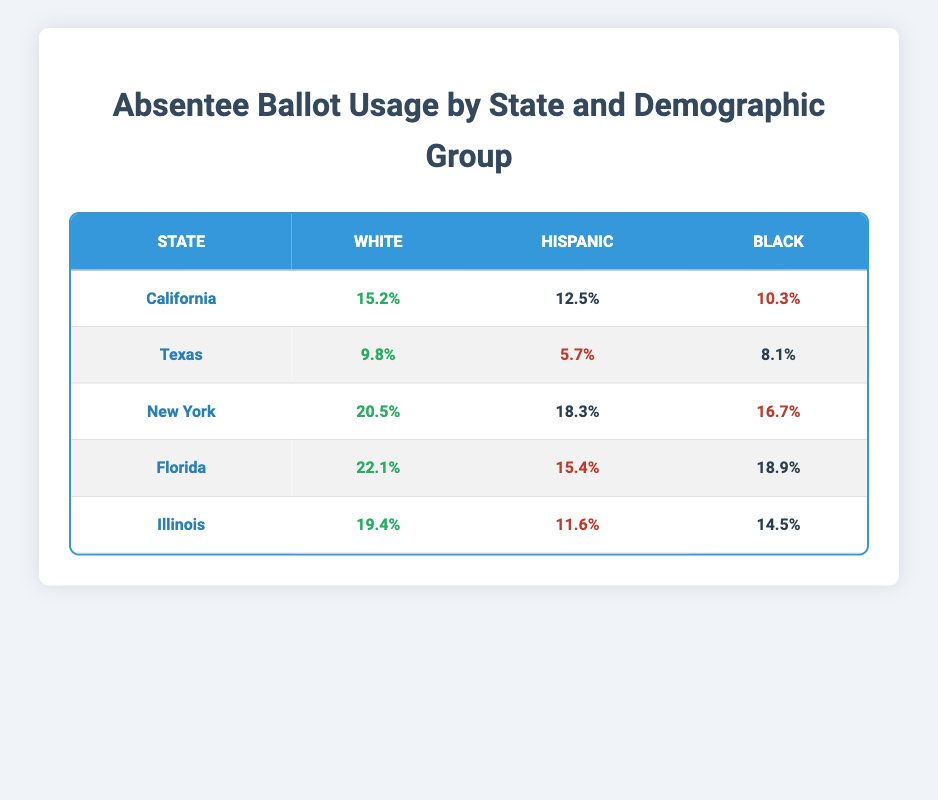What is the absentee ballot usage percentage for White voters in Florida? The table shows Florida's absentee ballot usage for the White demographic group as 22.1%.
Answer: 22.1% Which state has the highest absentee ballot usage percentage for Hispanic voters? By examining the table, New York exhibits the highest absentee ballot usage percentage for Hispanic voters at 18.3%.
Answer: New York What is the average absentee ballot usage percentage for Black voters across all states? The percentages for Black voters are 10.3 (California), 8.1 (Texas), 16.7 (New York), 18.9 (Florida), and 14.5 (Illinois). The sum is 10.3 + 8.1 + 16.7 + 18.9 + 14.5 = 68.5. There are 5 data points, so the average is 68.5 / 5 = 13.7.
Answer: 13.7 Does absentee ballot usage for Hispanic voters in Texas exceed that of Black voters in the same state? The table shows Hispanic absentee ballot usage in Texas is 5.7%, and Black voter usage is 8.1%. Since 5.7% is less than 8.1%, the statement is false.
Answer: No Which demographic group has the lowest absentee ballot usage percentage in California? In California, the percentages are 15.2% for White, 12.5% for Hispanic, and 10.3% for Black voters. The lowest is clearly 10.3% for Black voters.
Answer: Black 